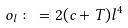<formula> <loc_0><loc_0><loc_500><loc_500>o _ { l } \colon = 2 ( c + T ) l ^ { 4 }</formula> 